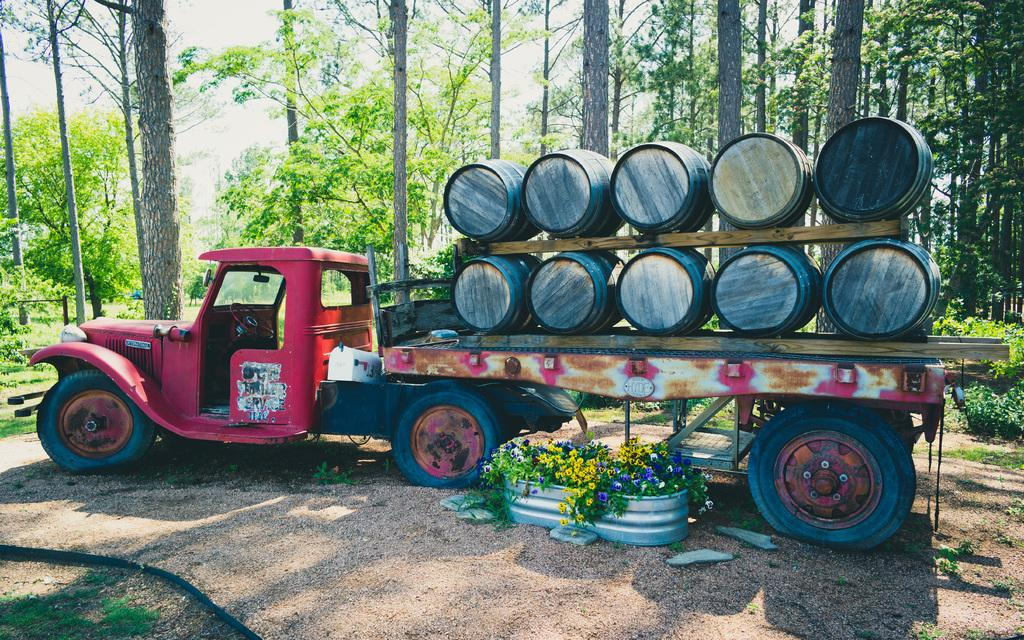What is parked on the ground in the image? There is a vehicle parked on the ground in the image. What type of objects made of wood can be seen in the image? There are wooden objects in the image. What type of vegetation is present in the image? There are plants and grass in the image. What can be seen in the background of the image? The background of the image includes trees, plants, and the sky. How many cakes are being used as a step in the image? There are no cakes present in the image, and therefore no cakes are being used as a step. What type of bead is visible on the wooden objects in the image? There are no beads visible on the wooden objects in the image. 